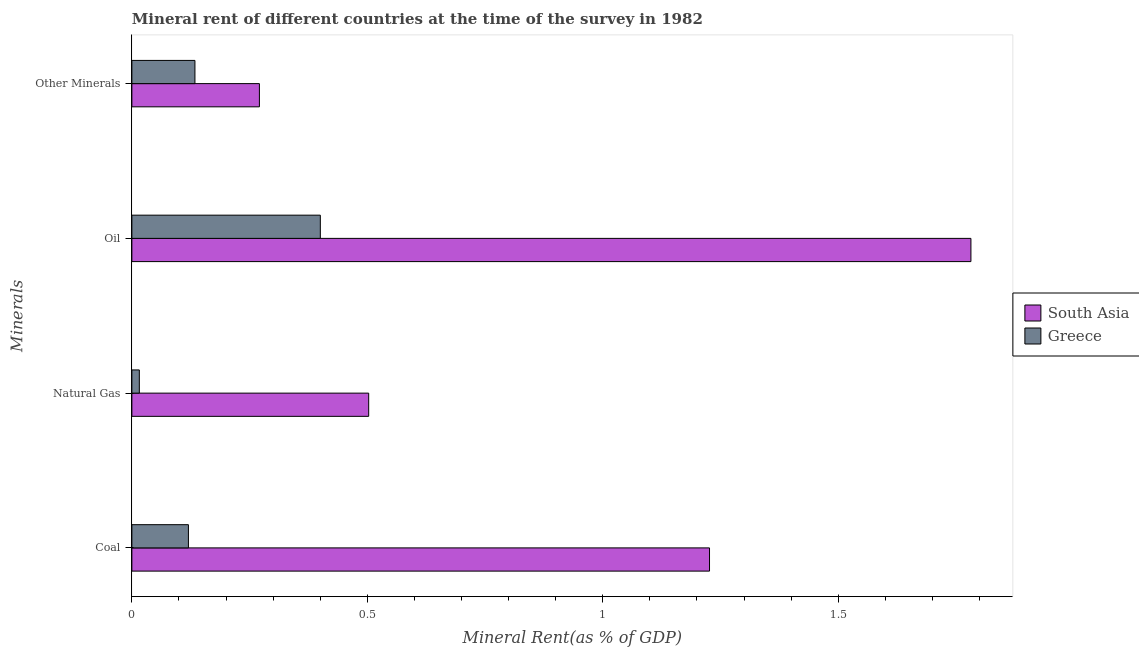How many different coloured bars are there?
Provide a short and direct response. 2. Are the number of bars on each tick of the Y-axis equal?
Your answer should be compact. Yes. What is the label of the 1st group of bars from the top?
Ensure brevity in your answer.  Other Minerals. What is the oil rent in Greece?
Your response must be concise. 0.4. Across all countries, what is the maximum natural gas rent?
Keep it short and to the point. 0.5. Across all countries, what is the minimum natural gas rent?
Your response must be concise. 0.02. What is the total  rent of other minerals in the graph?
Your answer should be very brief. 0.4. What is the difference between the natural gas rent in South Asia and that in Greece?
Your answer should be compact. 0.49. What is the difference between the natural gas rent in South Asia and the oil rent in Greece?
Ensure brevity in your answer.  0.1. What is the average coal rent per country?
Your response must be concise. 0.67. What is the difference between the  rent of other minerals and natural gas rent in South Asia?
Keep it short and to the point. -0.23. In how many countries, is the  rent of other minerals greater than 1.6 %?
Keep it short and to the point. 0. What is the ratio of the oil rent in South Asia to that in Greece?
Ensure brevity in your answer.  4.45. Is the oil rent in Greece less than that in South Asia?
Your answer should be compact. Yes. Is the difference between the oil rent in South Asia and Greece greater than the difference between the natural gas rent in South Asia and Greece?
Offer a very short reply. Yes. What is the difference between the highest and the second highest  rent of other minerals?
Provide a succinct answer. 0.14. What is the difference between the highest and the lowest natural gas rent?
Your answer should be compact. 0.49. What does the 1st bar from the top in Natural Gas represents?
Make the answer very short. Greece. Is it the case that in every country, the sum of the coal rent and natural gas rent is greater than the oil rent?
Provide a succinct answer. No. Are all the bars in the graph horizontal?
Provide a short and direct response. Yes. How many countries are there in the graph?
Your answer should be very brief. 2. Are the values on the major ticks of X-axis written in scientific E-notation?
Your answer should be very brief. No. Does the graph contain any zero values?
Offer a terse response. No. What is the title of the graph?
Give a very brief answer. Mineral rent of different countries at the time of the survey in 1982. Does "Fiji" appear as one of the legend labels in the graph?
Keep it short and to the point. No. What is the label or title of the X-axis?
Provide a short and direct response. Mineral Rent(as % of GDP). What is the label or title of the Y-axis?
Provide a short and direct response. Minerals. What is the Mineral Rent(as % of GDP) in South Asia in Coal?
Offer a very short reply. 1.23. What is the Mineral Rent(as % of GDP) in Greece in Coal?
Offer a very short reply. 0.12. What is the Mineral Rent(as % of GDP) in South Asia in Natural Gas?
Provide a succinct answer. 0.5. What is the Mineral Rent(as % of GDP) of Greece in Natural Gas?
Offer a terse response. 0.02. What is the Mineral Rent(as % of GDP) in South Asia in Oil?
Your answer should be compact. 1.78. What is the Mineral Rent(as % of GDP) in Greece in Oil?
Your answer should be very brief. 0.4. What is the Mineral Rent(as % of GDP) in South Asia in Other Minerals?
Offer a terse response. 0.27. What is the Mineral Rent(as % of GDP) of Greece in Other Minerals?
Your response must be concise. 0.13. Across all Minerals, what is the maximum Mineral Rent(as % of GDP) of South Asia?
Provide a short and direct response. 1.78. Across all Minerals, what is the maximum Mineral Rent(as % of GDP) in Greece?
Keep it short and to the point. 0.4. Across all Minerals, what is the minimum Mineral Rent(as % of GDP) of South Asia?
Provide a succinct answer. 0.27. Across all Minerals, what is the minimum Mineral Rent(as % of GDP) in Greece?
Your response must be concise. 0.02. What is the total Mineral Rent(as % of GDP) in South Asia in the graph?
Offer a very short reply. 3.78. What is the total Mineral Rent(as % of GDP) in Greece in the graph?
Provide a succinct answer. 0.67. What is the difference between the Mineral Rent(as % of GDP) of South Asia in Coal and that in Natural Gas?
Your answer should be very brief. 0.72. What is the difference between the Mineral Rent(as % of GDP) in Greece in Coal and that in Natural Gas?
Offer a terse response. 0.1. What is the difference between the Mineral Rent(as % of GDP) of South Asia in Coal and that in Oil?
Offer a terse response. -0.56. What is the difference between the Mineral Rent(as % of GDP) of Greece in Coal and that in Oil?
Give a very brief answer. -0.28. What is the difference between the Mineral Rent(as % of GDP) in South Asia in Coal and that in Other Minerals?
Ensure brevity in your answer.  0.96. What is the difference between the Mineral Rent(as % of GDP) in Greece in Coal and that in Other Minerals?
Your answer should be compact. -0.01. What is the difference between the Mineral Rent(as % of GDP) of South Asia in Natural Gas and that in Oil?
Your answer should be very brief. -1.28. What is the difference between the Mineral Rent(as % of GDP) of Greece in Natural Gas and that in Oil?
Provide a succinct answer. -0.38. What is the difference between the Mineral Rent(as % of GDP) of South Asia in Natural Gas and that in Other Minerals?
Your answer should be compact. 0.23. What is the difference between the Mineral Rent(as % of GDP) in Greece in Natural Gas and that in Other Minerals?
Your answer should be compact. -0.12. What is the difference between the Mineral Rent(as % of GDP) of South Asia in Oil and that in Other Minerals?
Your response must be concise. 1.51. What is the difference between the Mineral Rent(as % of GDP) in Greece in Oil and that in Other Minerals?
Make the answer very short. 0.27. What is the difference between the Mineral Rent(as % of GDP) in South Asia in Coal and the Mineral Rent(as % of GDP) in Greece in Natural Gas?
Your answer should be compact. 1.21. What is the difference between the Mineral Rent(as % of GDP) of South Asia in Coal and the Mineral Rent(as % of GDP) of Greece in Oil?
Your answer should be compact. 0.83. What is the difference between the Mineral Rent(as % of GDP) in South Asia in Coal and the Mineral Rent(as % of GDP) in Greece in Other Minerals?
Provide a succinct answer. 1.09. What is the difference between the Mineral Rent(as % of GDP) of South Asia in Natural Gas and the Mineral Rent(as % of GDP) of Greece in Oil?
Provide a succinct answer. 0.1. What is the difference between the Mineral Rent(as % of GDP) in South Asia in Natural Gas and the Mineral Rent(as % of GDP) in Greece in Other Minerals?
Make the answer very short. 0.37. What is the difference between the Mineral Rent(as % of GDP) in South Asia in Oil and the Mineral Rent(as % of GDP) in Greece in Other Minerals?
Keep it short and to the point. 1.65. What is the average Mineral Rent(as % of GDP) in South Asia per Minerals?
Offer a very short reply. 0.95. What is the average Mineral Rent(as % of GDP) of Greece per Minerals?
Offer a very short reply. 0.17. What is the difference between the Mineral Rent(as % of GDP) of South Asia and Mineral Rent(as % of GDP) of Greece in Coal?
Offer a terse response. 1.11. What is the difference between the Mineral Rent(as % of GDP) in South Asia and Mineral Rent(as % of GDP) in Greece in Natural Gas?
Make the answer very short. 0.49. What is the difference between the Mineral Rent(as % of GDP) of South Asia and Mineral Rent(as % of GDP) of Greece in Oil?
Offer a very short reply. 1.38. What is the difference between the Mineral Rent(as % of GDP) in South Asia and Mineral Rent(as % of GDP) in Greece in Other Minerals?
Your answer should be very brief. 0.14. What is the ratio of the Mineral Rent(as % of GDP) in South Asia in Coal to that in Natural Gas?
Give a very brief answer. 2.44. What is the ratio of the Mineral Rent(as % of GDP) in Greece in Coal to that in Natural Gas?
Your response must be concise. 7.58. What is the ratio of the Mineral Rent(as % of GDP) in South Asia in Coal to that in Oil?
Provide a succinct answer. 0.69. What is the ratio of the Mineral Rent(as % of GDP) of Greece in Coal to that in Oil?
Your response must be concise. 0.3. What is the ratio of the Mineral Rent(as % of GDP) of South Asia in Coal to that in Other Minerals?
Provide a succinct answer. 4.53. What is the ratio of the Mineral Rent(as % of GDP) of Greece in Coal to that in Other Minerals?
Give a very brief answer. 0.9. What is the ratio of the Mineral Rent(as % of GDP) of South Asia in Natural Gas to that in Oil?
Provide a short and direct response. 0.28. What is the ratio of the Mineral Rent(as % of GDP) in Greece in Natural Gas to that in Oil?
Make the answer very short. 0.04. What is the ratio of the Mineral Rent(as % of GDP) in South Asia in Natural Gas to that in Other Minerals?
Keep it short and to the point. 1.86. What is the ratio of the Mineral Rent(as % of GDP) in Greece in Natural Gas to that in Other Minerals?
Your response must be concise. 0.12. What is the ratio of the Mineral Rent(as % of GDP) in South Asia in Oil to that in Other Minerals?
Your answer should be compact. 6.58. What is the ratio of the Mineral Rent(as % of GDP) of Greece in Oil to that in Other Minerals?
Ensure brevity in your answer.  2.99. What is the difference between the highest and the second highest Mineral Rent(as % of GDP) of South Asia?
Offer a terse response. 0.56. What is the difference between the highest and the second highest Mineral Rent(as % of GDP) in Greece?
Give a very brief answer. 0.27. What is the difference between the highest and the lowest Mineral Rent(as % of GDP) of South Asia?
Your answer should be very brief. 1.51. What is the difference between the highest and the lowest Mineral Rent(as % of GDP) in Greece?
Offer a very short reply. 0.38. 